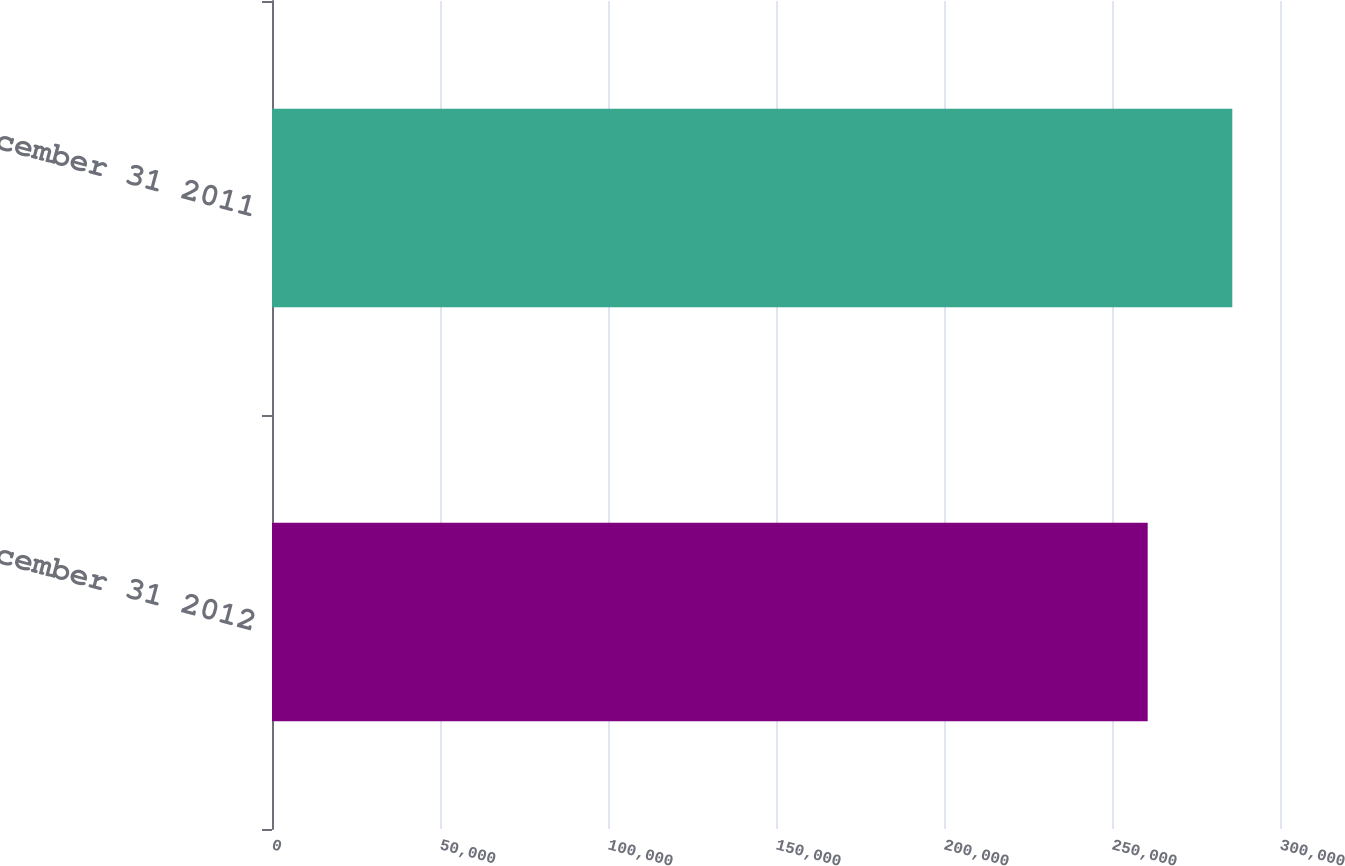Convert chart. <chart><loc_0><loc_0><loc_500><loc_500><bar_chart><fcel>December 31 2012<fcel>December 31 2011<nl><fcel>260622<fcel>285805<nl></chart> 